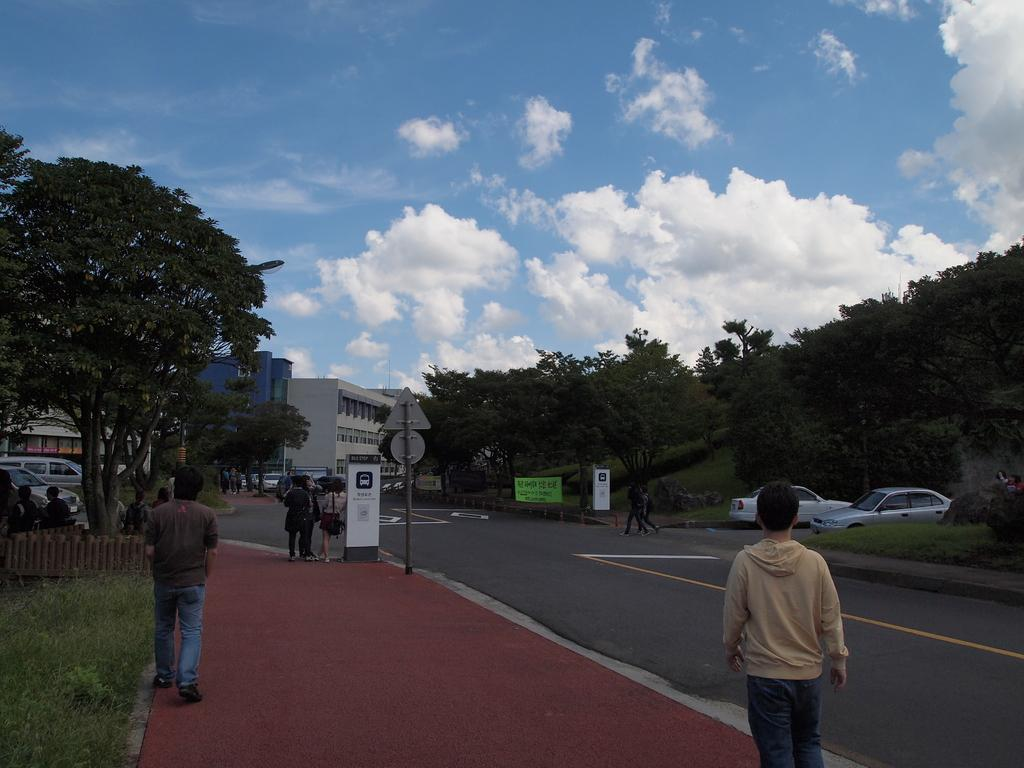What can be seen in the sky in the background of the image? There are clouds in the sky in the background of the image. What type of structures are present in the image? There are buildings in the image. What objects are present in the image that might be used for displaying information or advertisements? There are boards in the image. What type of vegetation is present in the image? There are trees in the image. What type of barrier is present in the image? There is a fence in the image. Who or what is present in the image? There are people in the image. What type of transportation is present in the image? There are vehicles in the image. What type of pathway is present in the image? There is a road in the image. What type of ground cover is present in the image? There is grass in the image. How many objects can be counted in the image? There are few objects in the image. Where is the doll located in the image? There is no doll present in the image. What type of plot is being developed in the image? There is no plot being developed in the image; it is a still photograph. What color is the cub in the image? There is no cub present in the image. 